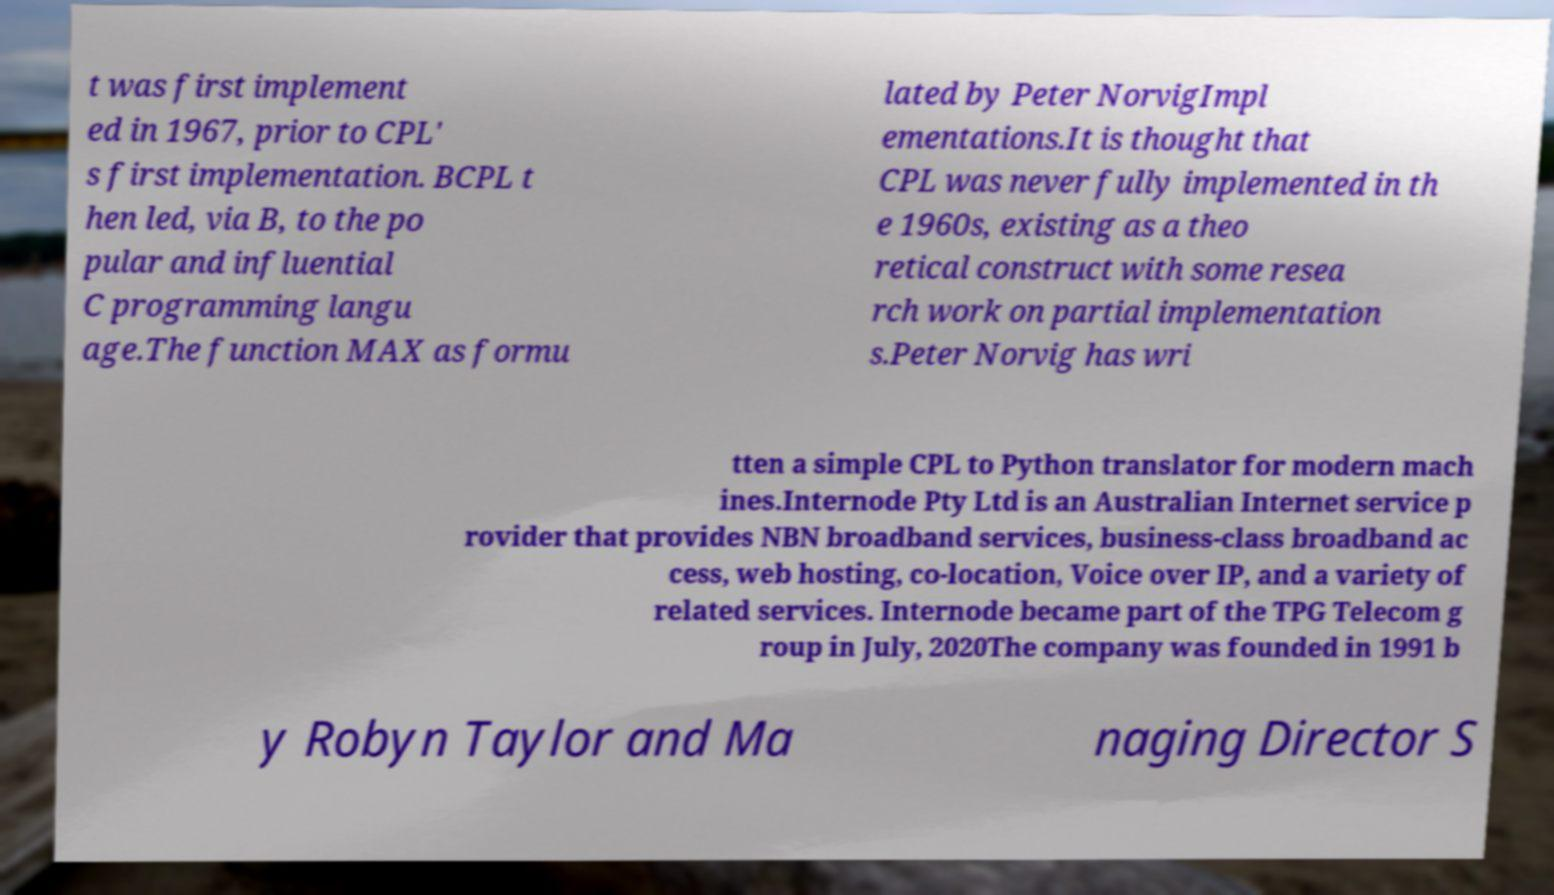For documentation purposes, I need the text within this image transcribed. Could you provide that? t was first implement ed in 1967, prior to CPL' s first implementation. BCPL t hen led, via B, to the po pular and influential C programming langu age.The function MAX as formu lated by Peter NorvigImpl ementations.It is thought that CPL was never fully implemented in th e 1960s, existing as a theo retical construct with some resea rch work on partial implementation s.Peter Norvig has wri tten a simple CPL to Python translator for modern mach ines.Internode Pty Ltd is an Australian Internet service p rovider that provides NBN broadband services, business-class broadband ac cess, web hosting, co-location, Voice over IP, and a variety of related services. Internode became part of the TPG Telecom g roup in July, 2020The company was founded in 1991 b y Robyn Taylor and Ma naging Director S 